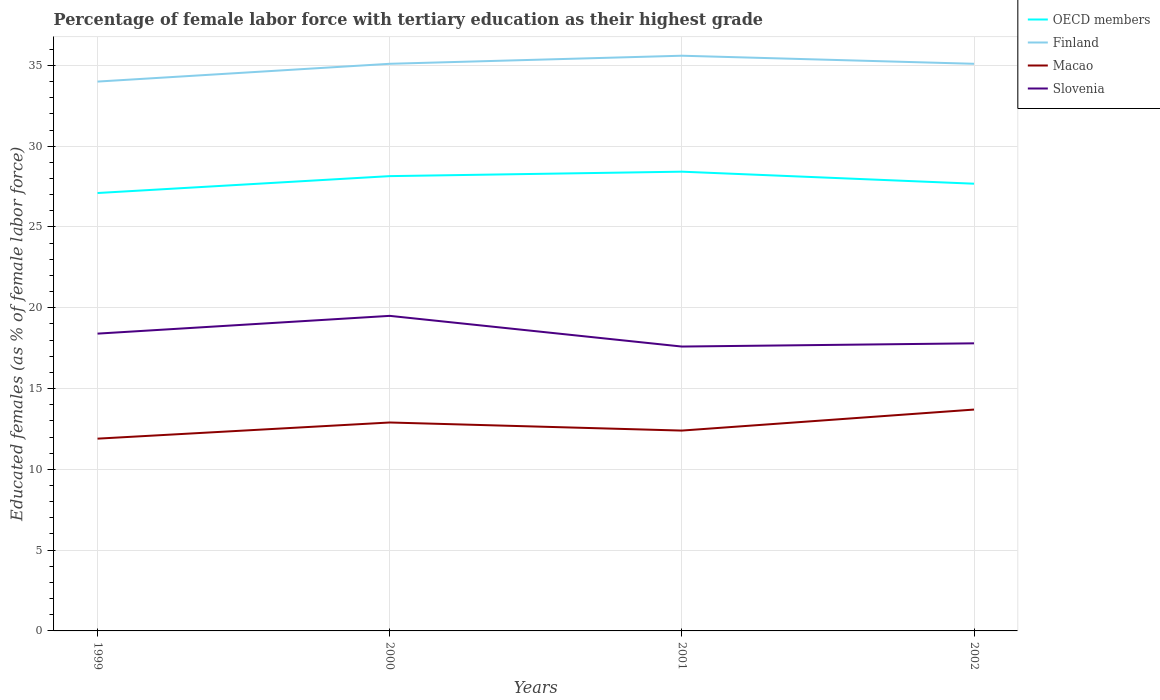How many different coloured lines are there?
Your response must be concise. 4. Is the number of lines equal to the number of legend labels?
Offer a terse response. Yes. Across all years, what is the maximum percentage of female labor force with tertiary education in Finland?
Provide a short and direct response. 34. What is the difference between the highest and the second highest percentage of female labor force with tertiary education in Finland?
Offer a very short reply. 1.6. Is the percentage of female labor force with tertiary education in Slovenia strictly greater than the percentage of female labor force with tertiary education in Macao over the years?
Your response must be concise. No. How many lines are there?
Make the answer very short. 4. What is the difference between two consecutive major ticks on the Y-axis?
Your answer should be very brief. 5. Does the graph contain grids?
Offer a very short reply. Yes. Where does the legend appear in the graph?
Make the answer very short. Top right. What is the title of the graph?
Make the answer very short. Percentage of female labor force with tertiary education as their highest grade. What is the label or title of the X-axis?
Give a very brief answer. Years. What is the label or title of the Y-axis?
Offer a very short reply. Educated females (as % of female labor force). What is the Educated females (as % of female labor force) of OECD members in 1999?
Offer a very short reply. 27.1. What is the Educated females (as % of female labor force) of Macao in 1999?
Make the answer very short. 11.9. What is the Educated females (as % of female labor force) in Slovenia in 1999?
Provide a short and direct response. 18.4. What is the Educated females (as % of female labor force) of OECD members in 2000?
Offer a terse response. 28.15. What is the Educated females (as % of female labor force) of Finland in 2000?
Offer a terse response. 35.1. What is the Educated females (as % of female labor force) in Macao in 2000?
Provide a short and direct response. 12.9. What is the Educated females (as % of female labor force) in Slovenia in 2000?
Your answer should be compact. 19.5. What is the Educated females (as % of female labor force) in OECD members in 2001?
Make the answer very short. 28.42. What is the Educated females (as % of female labor force) of Finland in 2001?
Your answer should be very brief. 35.6. What is the Educated females (as % of female labor force) of Macao in 2001?
Provide a short and direct response. 12.4. What is the Educated females (as % of female labor force) of Slovenia in 2001?
Offer a terse response. 17.6. What is the Educated females (as % of female labor force) of OECD members in 2002?
Offer a terse response. 27.68. What is the Educated females (as % of female labor force) of Finland in 2002?
Provide a succinct answer. 35.1. What is the Educated females (as % of female labor force) in Macao in 2002?
Offer a terse response. 13.7. What is the Educated females (as % of female labor force) in Slovenia in 2002?
Your answer should be very brief. 17.8. Across all years, what is the maximum Educated females (as % of female labor force) in OECD members?
Provide a succinct answer. 28.42. Across all years, what is the maximum Educated females (as % of female labor force) in Finland?
Give a very brief answer. 35.6. Across all years, what is the maximum Educated females (as % of female labor force) in Macao?
Your answer should be compact. 13.7. Across all years, what is the maximum Educated females (as % of female labor force) of Slovenia?
Ensure brevity in your answer.  19.5. Across all years, what is the minimum Educated females (as % of female labor force) of OECD members?
Your response must be concise. 27.1. Across all years, what is the minimum Educated females (as % of female labor force) of Macao?
Your answer should be very brief. 11.9. Across all years, what is the minimum Educated females (as % of female labor force) of Slovenia?
Give a very brief answer. 17.6. What is the total Educated females (as % of female labor force) in OECD members in the graph?
Ensure brevity in your answer.  111.35. What is the total Educated females (as % of female labor force) in Finland in the graph?
Ensure brevity in your answer.  139.8. What is the total Educated females (as % of female labor force) in Macao in the graph?
Provide a short and direct response. 50.9. What is the total Educated females (as % of female labor force) of Slovenia in the graph?
Ensure brevity in your answer.  73.3. What is the difference between the Educated females (as % of female labor force) in OECD members in 1999 and that in 2000?
Provide a succinct answer. -1.05. What is the difference between the Educated females (as % of female labor force) in Finland in 1999 and that in 2000?
Your answer should be very brief. -1.1. What is the difference between the Educated females (as % of female labor force) in OECD members in 1999 and that in 2001?
Keep it short and to the point. -1.32. What is the difference between the Educated females (as % of female labor force) in Finland in 1999 and that in 2001?
Offer a terse response. -1.6. What is the difference between the Educated females (as % of female labor force) of Macao in 1999 and that in 2001?
Your answer should be compact. -0.5. What is the difference between the Educated females (as % of female labor force) of OECD members in 1999 and that in 2002?
Your response must be concise. -0.58. What is the difference between the Educated females (as % of female labor force) in Finland in 1999 and that in 2002?
Provide a short and direct response. -1.1. What is the difference between the Educated females (as % of female labor force) in Macao in 1999 and that in 2002?
Provide a succinct answer. -1.8. What is the difference between the Educated females (as % of female labor force) in Slovenia in 1999 and that in 2002?
Ensure brevity in your answer.  0.6. What is the difference between the Educated females (as % of female labor force) in OECD members in 2000 and that in 2001?
Make the answer very short. -0.28. What is the difference between the Educated females (as % of female labor force) of Finland in 2000 and that in 2001?
Make the answer very short. -0.5. What is the difference between the Educated females (as % of female labor force) of Macao in 2000 and that in 2001?
Your response must be concise. 0.5. What is the difference between the Educated females (as % of female labor force) of Slovenia in 2000 and that in 2001?
Your answer should be very brief. 1.9. What is the difference between the Educated females (as % of female labor force) in OECD members in 2000 and that in 2002?
Keep it short and to the point. 0.47. What is the difference between the Educated females (as % of female labor force) in Slovenia in 2000 and that in 2002?
Offer a very short reply. 1.7. What is the difference between the Educated females (as % of female labor force) of OECD members in 2001 and that in 2002?
Ensure brevity in your answer.  0.74. What is the difference between the Educated females (as % of female labor force) in Finland in 2001 and that in 2002?
Your response must be concise. 0.5. What is the difference between the Educated females (as % of female labor force) of Macao in 2001 and that in 2002?
Provide a succinct answer. -1.3. What is the difference between the Educated females (as % of female labor force) in OECD members in 1999 and the Educated females (as % of female labor force) in Finland in 2000?
Your answer should be very brief. -8. What is the difference between the Educated females (as % of female labor force) of OECD members in 1999 and the Educated females (as % of female labor force) of Macao in 2000?
Make the answer very short. 14.2. What is the difference between the Educated females (as % of female labor force) in OECD members in 1999 and the Educated females (as % of female labor force) in Slovenia in 2000?
Keep it short and to the point. 7.6. What is the difference between the Educated females (as % of female labor force) in Finland in 1999 and the Educated females (as % of female labor force) in Macao in 2000?
Your response must be concise. 21.1. What is the difference between the Educated females (as % of female labor force) of OECD members in 1999 and the Educated females (as % of female labor force) of Finland in 2001?
Provide a short and direct response. -8.5. What is the difference between the Educated females (as % of female labor force) in OECD members in 1999 and the Educated females (as % of female labor force) in Macao in 2001?
Offer a terse response. 14.7. What is the difference between the Educated females (as % of female labor force) of OECD members in 1999 and the Educated females (as % of female labor force) of Slovenia in 2001?
Provide a succinct answer. 9.5. What is the difference between the Educated females (as % of female labor force) in Finland in 1999 and the Educated females (as % of female labor force) in Macao in 2001?
Offer a terse response. 21.6. What is the difference between the Educated females (as % of female labor force) of OECD members in 1999 and the Educated females (as % of female labor force) of Finland in 2002?
Your answer should be very brief. -8. What is the difference between the Educated females (as % of female labor force) in OECD members in 1999 and the Educated females (as % of female labor force) in Macao in 2002?
Offer a terse response. 13.4. What is the difference between the Educated females (as % of female labor force) in OECD members in 1999 and the Educated females (as % of female labor force) in Slovenia in 2002?
Your answer should be very brief. 9.3. What is the difference between the Educated females (as % of female labor force) of Finland in 1999 and the Educated females (as % of female labor force) of Macao in 2002?
Ensure brevity in your answer.  20.3. What is the difference between the Educated females (as % of female labor force) in Finland in 1999 and the Educated females (as % of female labor force) in Slovenia in 2002?
Your response must be concise. 16.2. What is the difference between the Educated females (as % of female labor force) of OECD members in 2000 and the Educated females (as % of female labor force) of Finland in 2001?
Offer a very short reply. -7.45. What is the difference between the Educated females (as % of female labor force) in OECD members in 2000 and the Educated females (as % of female labor force) in Macao in 2001?
Offer a terse response. 15.75. What is the difference between the Educated females (as % of female labor force) of OECD members in 2000 and the Educated females (as % of female labor force) of Slovenia in 2001?
Your response must be concise. 10.55. What is the difference between the Educated females (as % of female labor force) in Finland in 2000 and the Educated females (as % of female labor force) in Macao in 2001?
Your answer should be very brief. 22.7. What is the difference between the Educated females (as % of female labor force) of OECD members in 2000 and the Educated females (as % of female labor force) of Finland in 2002?
Your answer should be very brief. -6.95. What is the difference between the Educated females (as % of female labor force) of OECD members in 2000 and the Educated females (as % of female labor force) of Macao in 2002?
Offer a terse response. 14.45. What is the difference between the Educated females (as % of female labor force) of OECD members in 2000 and the Educated females (as % of female labor force) of Slovenia in 2002?
Offer a terse response. 10.35. What is the difference between the Educated females (as % of female labor force) in Finland in 2000 and the Educated females (as % of female labor force) in Macao in 2002?
Make the answer very short. 21.4. What is the difference between the Educated females (as % of female labor force) of Finland in 2000 and the Educated females (as % of female labor force) of Slovenia in 2002?
Your answer should be very brief. 17.3. What is the difference between the Educated females (as % of female labor force) of Macao in 2000 and the Educated females (as % of female labor force) of Slovenia in 2002?
Make the answer very short. -4.9. What is the difference between the Educated females (as % of female labor force) in OECD members in 2001 and the Educated females (as % of female labor force) in Finland in 2002?
Offer a terse response. -6.68. What is the difference between the Educated females (as % of female labor force) of OECD members in 2001 and the Educated females (as % of female labor force) of Macao in 2002?
Ensure brevity in your answer.  14.72. What is the difference between the Educated females (as % of female labor force) of OECD members in 2001 and the Educated females (as % of female labor force) of Slovenia in 2002?
Keep it short and to the point. 10.62. What is the difference between the Educated females (as % of female labor force) in Finland in 2001 and the Educated females (as % of female labor force) in Macao in 2002?
Ensure brevity in your answer.  21.9. What is the difference between the Educated females (as % of female labor force) in Macao in 2001 and the Educated females (as % of female labor force) in Slovenia in 2002?
Offer a very short reply. -5.4. What is the average Educated females (as % of female labor force) in OECD members per year?
Offer a terse response. 27.84. What is the average Educated females (as % of female labor force) of Finland per year?
Keep it short and to the point. 34.95. What is the average Educated females (as % of female labor force) of Macao per year?
Keep it short and to the point. 12.72. What is the average Educated females (as % of female labor force) in Slovenia per year?
Offer a very short reply. 18.32. In the year 1999, what is the difference between the Educated females (as % of female labor force) of OECD members and Educated females (as % of female labor force) of Finland?
Your response must be concise. -6.9. In the year 1999, what is the difference between the Educated females (as % of female labor force) in OECD members and Educated females (as % of female labor force) in Macao?
Make the answer very short. 15.2. In the year 1999, what is the difference between the Educated females (as % of female labor force) in OECD members and Educated females (as % of female labor force) in Slovenia?
Provide a short and direct response. 8.7. In the year 1999, what is the difference between the Educated females (as % of female labor force) of Finland and Educated females (as % of female labor force) of Macao?
Provide a succinct answer. 22.1. In the year 2000, what is the difference between the Educated females (as % of female labor force) in OECD members and Educated females (as % of female labor force) in Finland?
Ensure brevity in your answer.  -6.95. In the year 2000, what is the difference between the Educated females (as % of female labor force) in OECD members and Educated females (as % of female labor force) in Macao?
Offer a terse response. 15.25. In the year 2000, what is the difference between the Educated females (as % of female labor force) of OECD members and Educated females (as % of female labor force) of Slovenia?
Offer a very short reply. 8.65. In the year 2000, what is the difference between the Educated females (as % of female labor force) of Finland and Educated females (as % of female labor force) of Macao?
Your answer should be very brief. 22.2. In the year 2000, what is the difference between the Educated females (as % of female labor force) of Finland and Educated females (as % of female labor force) of Slovenia?
Your answer should be compact. 15.6. In the year 2001, what is the difference between the Educated females (as % of female labor force) of OECD members and Educated females (as % of female labor force) of Finland?
Provide a short and direct response. -7.18. In the year 2001, what is the difference between the Educated females (as % of female labor force) in OECD members and Educated females (as % of female labor force) in Macao?
Offer a terse response. 16.02. In the year 2001, what is the difference between the Educated females (as % of female labor force) in OECD members and Educated females (as % of female labor force) in Slovenia?
Your answer should be compact. 10.82. In the year 2001, what is the difference between the Educated females (as % of female labor force) in Finland and Educated females (as % of female labor force) in Macao?
Your answer should be very brief. 23.2. In the year 2002, what is the difference between the Educated females (as % of female labor force) of OECD members and Educated females (as % of female labor force) of Finland?
Provide a short and direct response. -7.42. In the year 2002, what is the difference between the Educated females (as % of female labor force) in OECD members and Educated females (as % of female labor force) in Macao?
Offer a very short reply. 13.98. In the year 2002, what is the difference between the Educated females (as % of female labor force) of OECD members and Educated females (as % of female labor force) of Slovenia?
Keep it short and to the point. 9.88. In the year 2002, what is the difference between the Educated females (as % of female labor force) of Finland and Educated females (as % of female labor force) of Macao?
Keep it short and to the point. 21.4. In the year 2002, what is the difference between the Educated females (as % of female labor force) of Finland and Educated females (as % of female labor force) of Slovenia?
Keep it short and to the point. 17.3. What is the ratio of the Educated females (as % of female labor force) in OECD members in 1999 to that in 2000?
Offer a very short reply. 0.96. What is the ratio of the Educated females (as % of female labor force) in Finland in 1999 to that in 2000?
Ensure brevity in your answer.  0.97. What is the ratio of the Educated females (as % of female labor force) in Macao in 1999 to that in 2000?
Offer a terse response. 0.92. What is the ratio of the Educated females (as % of female labor force) of Slovenia in 1999 to that in 2000?
Provide a succinct answer. 0.94. What is the ratio of the Educated females (as % of female labor force) of OECD members in 1999 to that in 2001?
Offer a very short reply. 0.95. What is the ratio of the Educated females (as % of female labor force) in Finland in 1999 to that in 2001?
Your response must be concise. 0.96. What is the ratio of the Educated females (as % of female labor force) in Macao in 1999 to that in 2001?
Offer a very short reply. 0.96. What is the ratio of the Educated females (as % of female labor force) of Slovenia in 1999 to that in 2001?
Offer a very short reply. 1.05. What is the ratio of the Educated females (as % of female labor force) of OECD members in 1999 to that in 2002?
Give a very brief answer. 0.98. What is the ratio of the Educated females (as % of female labor force) of Finland in 1999 to that in 2002?
Ensure brevity in your answer.  0.97. What is the ratio of the Educated females (as % of female labor force) in Macao in 1999 to that in 2002?
Provide a succinct answer. 0.87. What is the ratio of the Educated females (as % of female labor force) of Slovenia in 1999 to that in 2002?
Keep it short and to the point. 1.03. What is the ratio of the Educated females (as % of female labor force) in OECD members in 2000 to that in 2001?
Offer a terse response. 0.99. What is the ratio of the Educated females (as % of female labor force) in Macao in 2000 to that in 2001?
Your answer should be very brief. 1.04. What is the ratio of the Educated females (as % of female labor force) in Slovenia in 2000 to that in 2001?
Make the answer very short. 1.11. What is the ratio of the Educated females (as % of female labor force) in OECD members in 2000 to that in 2002?
Ensure brevity in your answer.  1.02. What is the ratio of the Educated females (as % of female labor force) in Finland in 2000 to that in 2002?
Ensure brevity in your answer.  1. What is the ratio of the Educated females (as % of female labor force) of Macao in 2000 to that in 2002?
Make the answer very short. 0.94. What is the ratio of the Educated females (as % of female labor force) of Slovenia in 2000 to that in 2002?
Ensure brevity in your answer.  1.1. What is the ratio of the Educated females (as % of female labor force) of OECD members in 2001 to that in 2002?
Your response must be concise. 1.03. What is the ratio of the Educated females (as % of female labor force) in Finland in 2001 to that in 2002?
Give a very brief answer. 1.01. What is the ratio of the Educated females (as % of female labor force) of Macao in 2001 to that in 2002?
Ensure brevity in your answer.  0.91. What is the ratio of the Educated females (as % of female labor force) in Slovenia in 2001 to that in 2002?
Give a very brief answer. 0.99. What is the difference between the highest and the second highest Educated females (as % of female labor force) in OECD members?
Keep it short and to the point. 0.28. What is the difference between the highest and the second highest Educated females (as % of female labor force) in Finland?
Offer a very short reply. 0.5. What is the difference between the highest and the second highest Educated females (as % of female labor force) in Macao?
Keep it short and to the point. 0.8. What is the difference between the highest and the lowest Educated females (as % of female labor force) of OECD members?
Give a very brief answer. 1.32. What is the difference between the highest and the lowest Educated females (as % of female labor force) in Finland?
Provide a short and direct response. 1.6. 